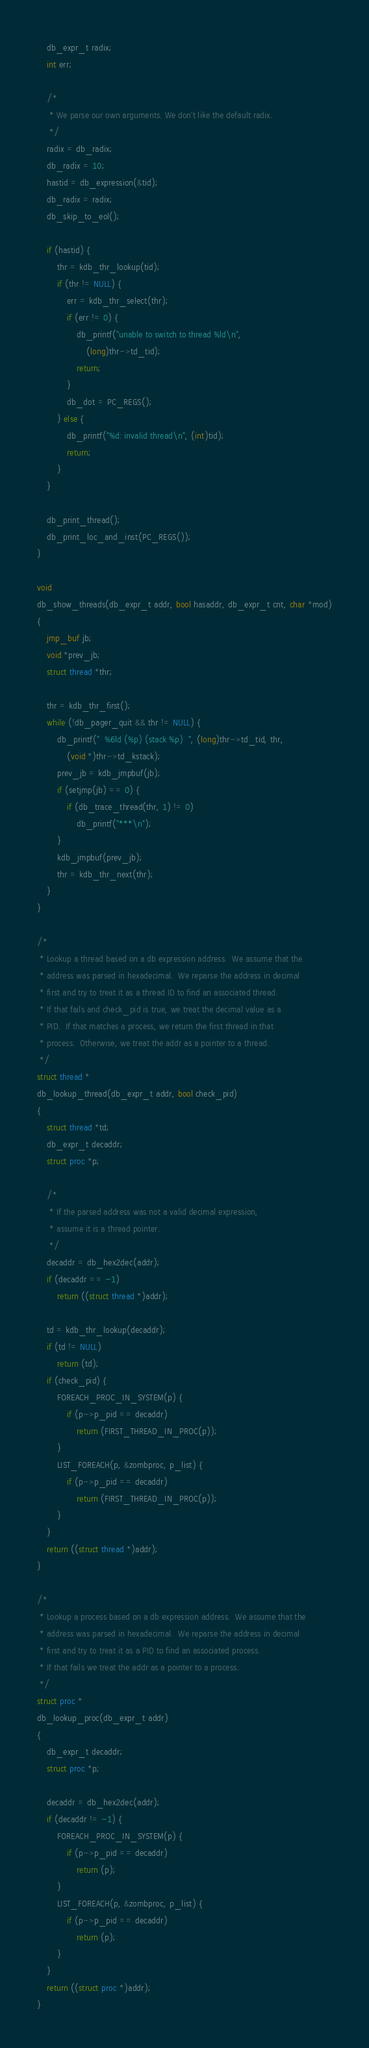Convert code to text. <code><loc_0><loc_0><loc_500><loc_500><_C_>	db_expr_t radix;
	int err;

	/*
	 * We parse our own arguments. We don't like the default radix.
	 */
	radix = db_radix;
	db_radix = 10;
	hastid = db_expression(&tid);
	db_radix = radix;
	db_skip_to_eol();

	if (hastid) {
		thr = kdb_thr_lookup(tid);
		if (thr != NULL) {
			err = kdb_thr_select(thr);
			if (err != 0) {
				db_printf("unable to switch to thread %ld\n",
				    (long)thr->td_tid);
				return;
			}
			db_dot = PC_REGS();
		} else {
			db_printf("%d: invalid thread\n", (int)tid);
			return;
		}
	}

	db_print_thread();
	db_print_loc_and_inst(PC_REGS());
}

void
db_show_threads(db_expr_t addr, bool hasaddr, db_expr_t cnt, char *mod)
{
	jmp_buf jb;
	void *prev_jb;
	struct thread *thr;

	thr = kdb_thr_first();
	while (!db_pager_quit && thr != NULL) {
		db_printf("  %6ld (%p) (stack %p)  ", (long)thr->td_tid, thr,
		    (void *)thr->td_kstack);
		prev_jb = kdb_jmpbuf(jb);
		if (setjmp(jb) == 0) {
			if (db_trace_thread(thr, 1) != 0)
				db_printf("***\n");
		}
		kdb_jmpbuf(prev_jb);
		thr = kdb_thr_next(thr);
	}
}

/*
 * Lookup a thread based on a db expression address.  We assume that the
 * address was parsed in hexadecimal.  We reparse the address in decimal
 * first and try to treat it as a thread ID to find an associated thread.
 * If that fails and check_pid is true, we treat the decimal value as a
 * PID.  If that matches a process, we return the first thread in that
 * process.  Otherwise, we treat the addr as a pointer to a thread.
 */
struct thread *
db_lookup_thread(db_expr_t addr, bool check_pid)
{
	struct thread *td;
	db_expr_t decaddr;
	struct proc *p;

	/*
	 * If the parsed address was not a valid decimal expression,
	 * assume it is a thread pointer.
	 */
	decaddr = db_hex2dec(addr);
	if (decaddr == -1)
		return ((struct thread *)addr);

	td = kdb_thr_lookup(decaddr);
	if (td != NULL)
		return (td);
	if (check_pid) {
		FOREACH_PROC_IN_SYSTEM(p) {
			if (p->p_pid == decaddr)
				return (FIRST_THREAD_IN_PROC(p));
		}
		LIST_FOREACH(p, &zombproc, p_list) {
			if (p->p_pid == decaddr)
				return (FIRST_THREAD_IN_PROC(p));
		}
	}
	return ((struct thread *)addr);
}

/*
 * Lookup a process based on a db expression address.  We assume that the
 * address was parsed in hexadecimal.  We reparse the address in decimal
 * first and try to treat it as a PID to find an associated process.
 * If that fails we treat the addr as a pointer to a process.
 */
struct proc *
db_lookup_proc(db_expr_t addr)
{
	db_expr_t decaddr;
	struct proc *p;

	decaddr = db_hex2dec(addr);
	if (decaddr != -1) {
		FOREACH_PROC_IN_SYSTEM(p) {
			if (p->p_pid == decaddr)
				return (p);
		}
		LIST_FOREACH(p, &zombproc, p_list) {
			if (p->p_pid == decaddr)
				return (p);
		}
	}
	return ((struct proc *)addr);
}
</code> 